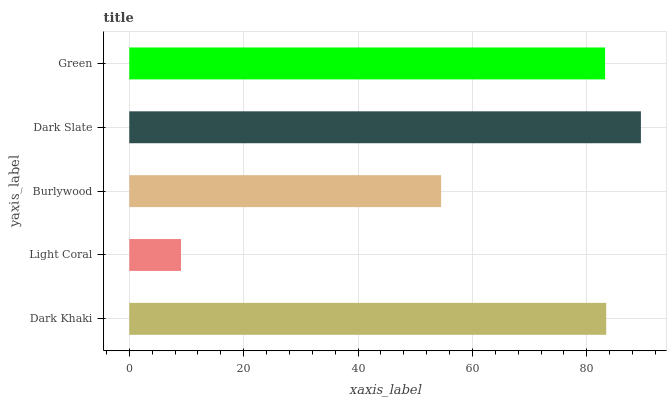Is Light Coral the minimum?
Answer yes or no. Yes. Is Dark Slate the maximum?
Answer yes or no. Yes. Is Burlywood the minimum?
Answer yes or no. No. Is Burlywood the maximum?
Answer yes or no. No. Is Burlywood greater than Light Coral?
Answer yes or no. Yes. Is Light Coral less than Burlywood?
Answer yes or no. Yes. Is Light Coral greater than Burlywood?
Answer yes or no. No. Is Burlywood less than Light Coral?
Answer yes or no. No. Is Green the high median?
Answer yes or no. Yes. Is Green the low median?
Answer yes or no. Yes. Is Light Coral the high median?
Answer yes or no. No. Is Burlywood the low median?
Answer yes or no. No. 